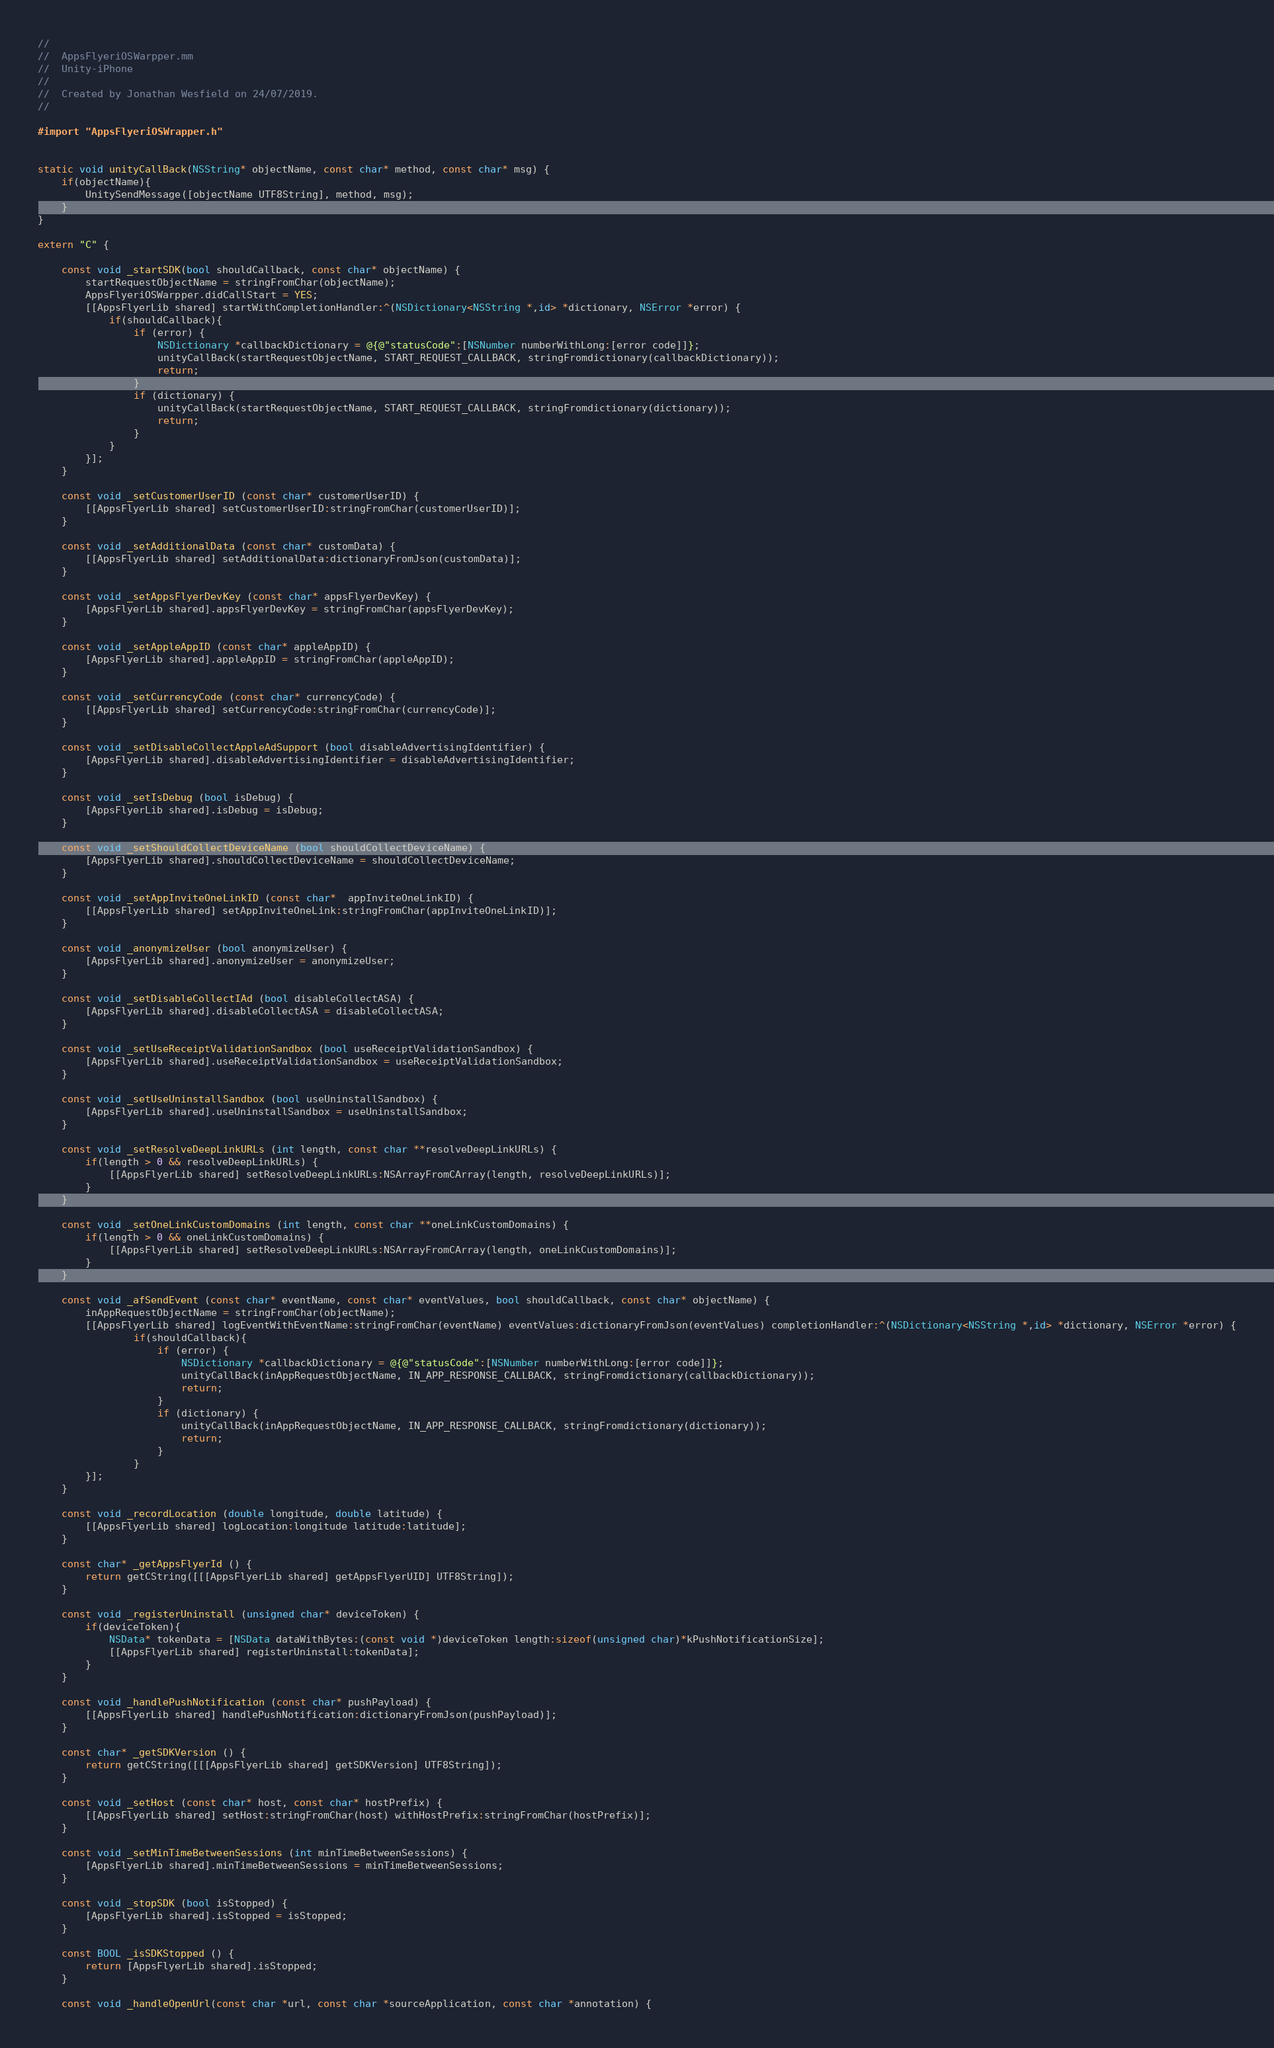<code> <loc_0><loc_0><loc_500><loc_500><_ObjectiveC_>//
//  AppsFlyeriOSWarpper.mm
//  Unity-iPhone
//
//  Created by Jonathan Wesfield on 24/07/2019.
//

#import "AppsFlyeriOSWrapper.h"


static void unityCallBack(NSString* objectName, const char* method, const char* msg) {
    if(objectName){
        UnitySendMessage([objectName UTF8String], method, msg);
    }
}

extern "C" {
 
    const void _startSDK(bool shouldCallback, const char* objectName) {
        startRequestObjectName = stringFromChar(objectName);
        AppsFlyeriOSWarpper.didCallStart = YES;
        [[AppsFlyerLib shared] startWithCompletionHandler:^(NSDictionary<NSString *,id> *dictionary, NSError *error) {
            if(shouldCallback){
                if (error) {
                    NSDictionary *callbackDictionary = @{@"statusCode":[NSNumber numberWithLong:[error code]]};
                    unityCallBack(startRequestObjectName, START_REQUEST_CALLBACK, stringFromdictionary(callbackDictionary));
                    return;
                }
                if (dictionary) {
                    unityCallBack(startRequestObjectName, START_REQUEST_CALLBACK, stringFromdictionary(dictionary));
                    return;
                }
            }
        }];
    }
    
    const void _setCustomerUserID (const char* customerUserID) {
        [[AppsFlyerLib shared] setCustomerUserID:stringFromChar(customerUserID)];
    }

    const void _setAdditionalData (const char* customData) {
        [[AppsFlyerLib shared] setAdditionalData:dictionaryFromJson(customData)];
    }

    const void _setAppsFlyerDevKey (const char* appsFlyerDevKey) {
        [AppsFlyerLib shared].appsFlyerDevKey = stringFromChar(appsFlyerDevKey);
    }

    const void _setAppleAppID (const char* appleAppID) {
        [AppsFlyerLib shared].appleAppID = stringFromChar(appleAppID);
    }

    const void _setCurrencyCode (const char* currencyCode) {
        [[AppsFlyerLib shared] setCurrencyCode:stringFromChar(currencyCode)];
    }

    const void _setDisableCollectAppleAdSupport (bool disableAdvertisingIdentifier) {
        [AppsFlyerLib shared].disableAdvertisingIdentifier = disableAdvertisingIdentifier;
    }

    const void _setIsDebug (bool isDebug) {
        [AppsFlyerLib shared].isDebug = isDebug;
    }

    const void _setShouldCollectDeviceName (bool shouldCollectDeviceName) {
        [AppsFlyerLib shared].shouldCollectDeviceName = shouldCollectDeviceName;
    }

    const void _setAppInviteOneLinkID (const char*  appInviteOneLinkID) {
        [[AppsFlyerLib shared] setAppInviteOneLink:stringFromChar(appInviteOneLinkID)];
    }

    const void _anonymizeUser (bool anonymizeUser) {
        [AppsFlyerLib shared].anonymizeUser = anonymizeUser;
    }

    const void _setDisableCollectIAd (bool disableCollectASA) {
        [AppsFlyerLib shared].disableCollectASA = disableCollectASA;
    }
    
    const void _setUseReceiptValidationSandbox (bool useReceiptValidationSandbox) {
        [AppsFlyerLib shared].useReceiptValidationSandbox = useReceiptValidationSandbox;
    }
    
    const void _setUseUninstallSandbox (bool useUninstallSandbox) {
        [AppsFlyerLib shared].useUninstallSandbox = useUninstallSandbox;
    }

    const void _setResolveDeepLinkURLs (int length, const char **resolveDeepLinkURLs) {
        if(length > 0 && resolveDeepLinkURLs) {
            [[AppsFlyerLib shared] setResolveDeepLinkURLs:NSArrayFromCArray(length, resolveDeepLinkURLs)];
        }
    }

    const void _setOneLinkCustomDomains (int length, const char **oneLinkCustomDomains) {
        if(length > 0 && oneLinkCustomDomains) {
            [[AppsFlyerLib shared] setResolveDeepLinkURLs:NSArrayFromCArray(length, oneLinkCustomDomains)];
        }
    }

    const void _afSendEvent (const char* eventName, const char* eventValues, bool shouldCallback, const char* objectName) {
        inAppRequestObjectName = stringFromChar(objectName);
        [[AppsFlyerLib shared] logEventWithEventName:stringFromChar(eventName) eventValues:dictionaryFromJson(eventValues) completionHandler:^(NSDictionary<NSString *,id> *dictionary, NSError *error) {
                if(shouldCallback){
                    if (error) {
                        NSDictionary *callbackDictionary = @{@"statusCode":[NSNumber numberWithLong:[error code]]};
                        unityCallBack(inAppRequestObjectName, IN_APP_RESPONSE_CALLBACK, stringFromdictionary(callbackDictionary));
                        return;
                    }
                    if (dictionary) {
                        unityCallBack(inAppRequestObjectName, IN_APP_RESPONSE_CALLBACK, stringFromdictionary(dictionary));
                        return;
                    }
                }
        }];
    }

    const void _recordLocation (double longitude, double latitude) {
        [[AppsFlyerLib shared] logLocation:longitude latitude:latitude];
    }

    const char* _getAppsFlyerId () {
        return getCString([[[AppsFlyerLib shared] getAppsFlyerUID] UTF8String]);
    }

    const void _registerUninstall (unsigned char* deviceToken) {
        if(deviceToken){
            NSData* tokenData = [NSData dataWithBytes:(const void *)deviceToken length:sizeof(unsigned char)*kPushNotificationSize];
            [[AppsFlyerLib shared] registerUninstall:tokenData];
        }
    }

    const void _handlePushNotification (const char* pushPayload) {
        [[AppsFlyerLib shared] handlePushNotification:dictionaryFromJson(pushPayload)];
    }

    const char* _getSDKVersion () {
        return getCString([[[AppsFlyerLib shared] getSDKVersion] UTF8String]);
    }

    const void _setHost (const char* host, const char* hostPrefix) {
        [[AppsFlyerLib shared] setHost:stringFromChar(host) withHostPrefix:stringFromChar(hostPrefix)];
    }

    const void _setMinTimeBetweenSessions (int minTimeBetweenSessions) {
        [AppsFlyerLib shared].minTimeBetweenSessions = minTimeBetweenSessions;
    }

    const void _stopSDK (bool isStopped) {
        [AppsFlyerLib shared].isStopped = isStopped;
    }

    const BOOL _isSDKStopped () {
        return [AppsFlyerLib shared].isStopped;
    }

    const void _handleOpenUrl(const char *url, const char *sourceApplication, const char *annotation) {</code> 